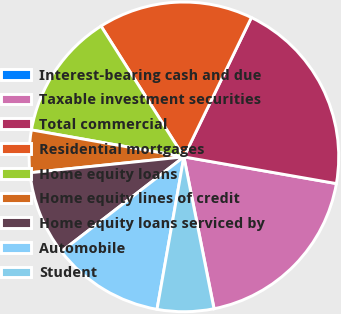<chart> <loc_0><loc_0><loc_500><loc_500><pie_chart><fcel>Interest-bearing cash and due<fcel>Taxable investment securities<fcel>Total commercial<fcel>Residential mortgages<fcel>Home equity loans<fcel>Home equity lines of credit<fcel>Home equity loans serviced by<fcel>Automobile<fcel>Student<nl><fcel>0.02%<fcel>19.11%<fcel>20.58%<fcel>16.17%<fcel>13.23%<fcel>4.42%<fcel>8.83%<fcel>11.76%<fcel>5.89%<nl></chart> 